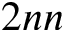<formula> <loc_0><loc_0><loc_500><loc_500>2 n n</formula> 